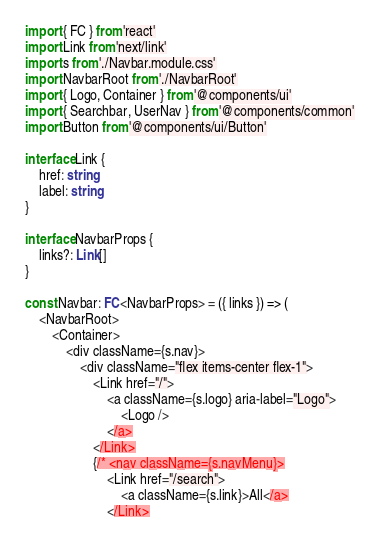Convert code to text. <code><loc_0><loc_0><loc_500><loc_500><_TypeScript_>import { FC } from 'react'
import Link from 'next/link'
import s from './Navbar.module.css'
import NavbarRoot from './NavbarRoot'
import { Logo, Container } from '@components/ui'
import { Searchbar, UserNav } from '@components/common'
import Button from '@components/ui/Button'

interface Link {
    href: string
    label: string
}

interface NavbarProps {
    links?: Link[]
}

const Navbar: FC<NavbarProps> = ({ links }) => (
    <NavbarRoot>
        <Container>
            <div className={s.nav}>
                <div className="flex items-center flex-1">
                    <Link href="/">
                        <a className={s.logo} aria-label="Logo">
                            <Logo />
                        </a>
                    </Link>
                    {/* <nav className={s.navMenu}>
                        <Link href="/search">
                            <a className={s.link}>All</a>
                        </Link></code> 